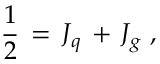Convert formula to latex. <formula><loc_0><loc_0><loc_500><loc_500>{ \frac { 1 } { 2 } } \, = \, J _ { q } \, + \, J _ { g } \, ,</formula> 